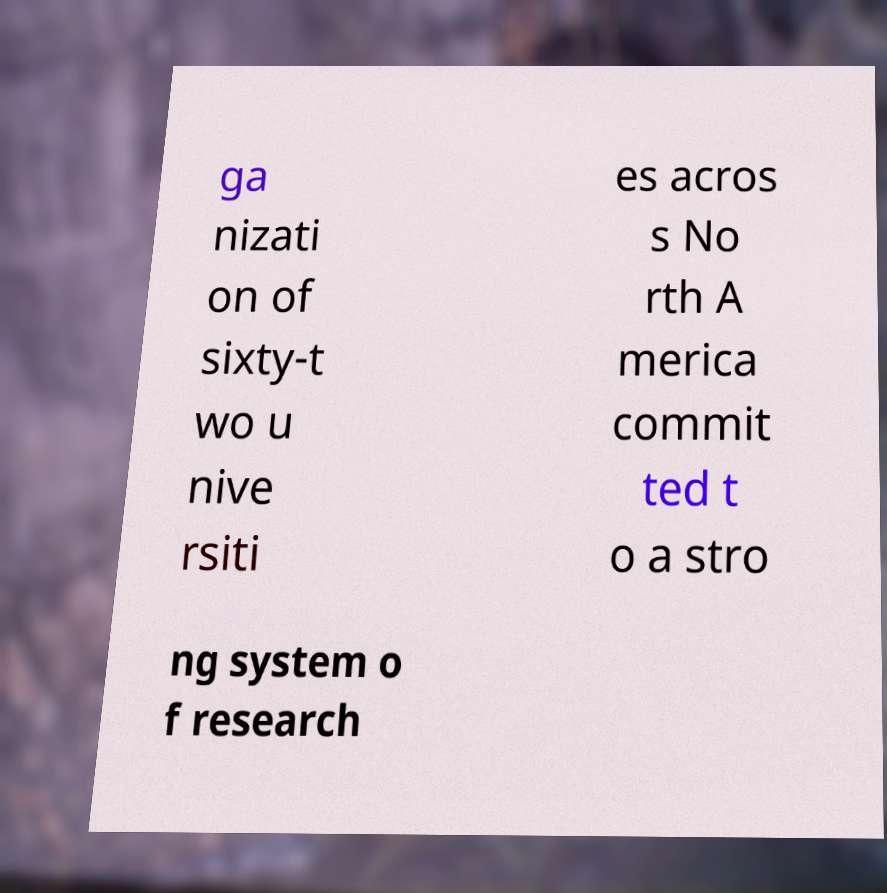What messages or text are displayed in this image? I need them in a readable, typed format. ga nizati on of sixty-t wo u nive rsiti es acros s No rth A merica commit ted t o a stro ng system o f research 